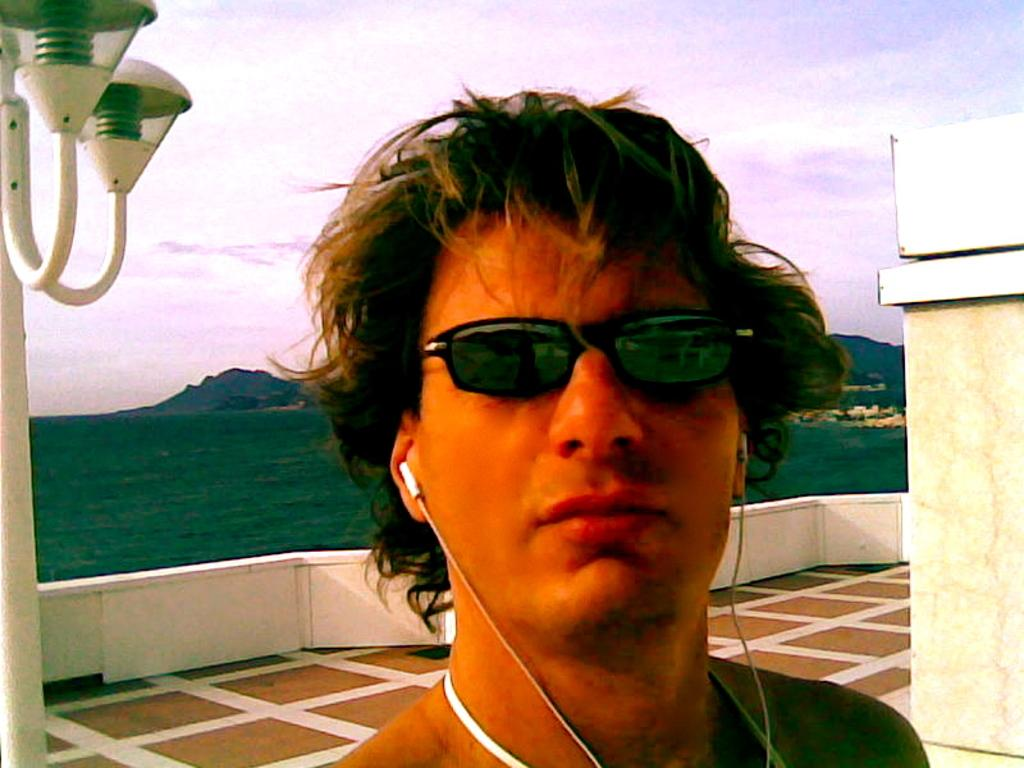Who is present in the image? There is a man in the image. What is located on the left side of the image? There is a light pole on the left side of the image. What is located on the right side of the image? There is a wall on the right side of the image. What type of natural environment is visible in the background of the image? There is green land and mountains visible in the background of the image. What is visible in the sky in the background of the image? The sky is visible in the background of the image. What type of orange can be seen in the image? There is no orange present in the image. What achievement has the rabbit accomplished in the image? There is no rabbit present in the image, and therefore no achievements can be attributed to it. 